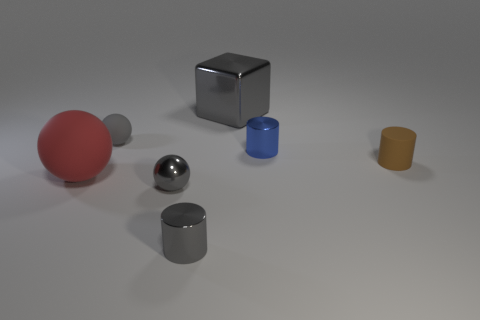What shape is the large object that is the same material as the tiny blue cylinder?
Your answer should be compact. Cube. How big is the gray thing on the left side of the metallic sphere?
Keep it short and to the point. Small. What is the shape of the small gray rubber thing?
Your answer should be very brief. Sphere. There is a ball on the right side of the gray rubber ball; is it the same size as the shiny object to the right of the large gray shiny object?
Offer a very short reply. Yes. There is a metal cylinder to the left of the big object to the right of the tiny gray thing in front of the small gray shiny sphere; what size is it?
Your response must be concise. Small. The shiny thing that is behind the small ball that is behind the large object to the left of the large gray metal block is what shape?
Your answer should be very brief. Cube. What shape is the tiny rubber object that is to the left of the brown matte thing?
Provide a short and direct response. Sphere. Is the material of the red sphere the same as the cylinder that is in front of the red matte sphere?
Provide a short and direct response. No. What number of other things are the same shape as the red rubber thing?
Offer a terse response. 2. There is a large matte sphere; is it the same color as the small sphere that is to the right of the small gray matte ball?
Give a very brief answer. No. 